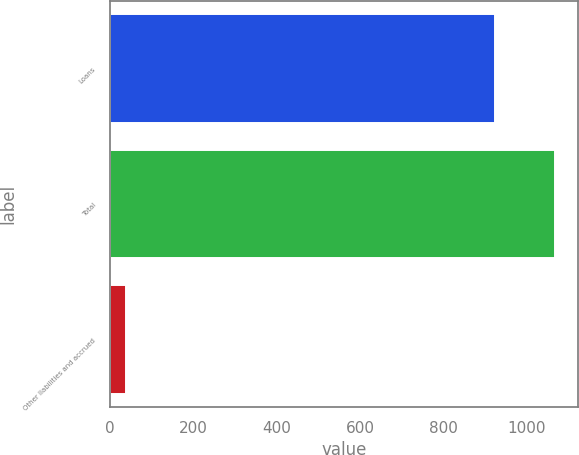<chart> <loc_0><loc_0><loc_500><loc_500><bar_chart><fcel>Loans<fcel>Total<fcel>Other liabilities and accrued<nl><fcel>924<fcel>1068<fcel>38<nl></chart> 